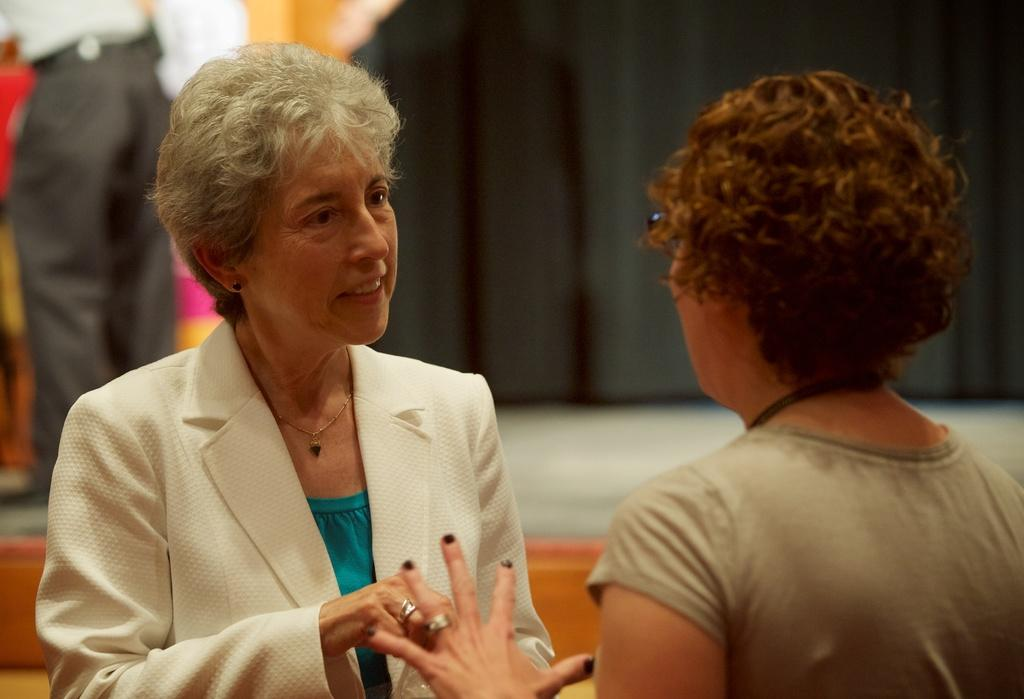How many people are in the foreground of the image? There are two ladies in the foreground of the image. What color is the curtain in the background of the image? There is a black color curtain in the background of the image. Can you describe the person in the image? There is a person standing in the image. What type of writing can be seen on the watch in the image? There is no watch present in the image, so it is not possible to determine what type of writing might be on it. 